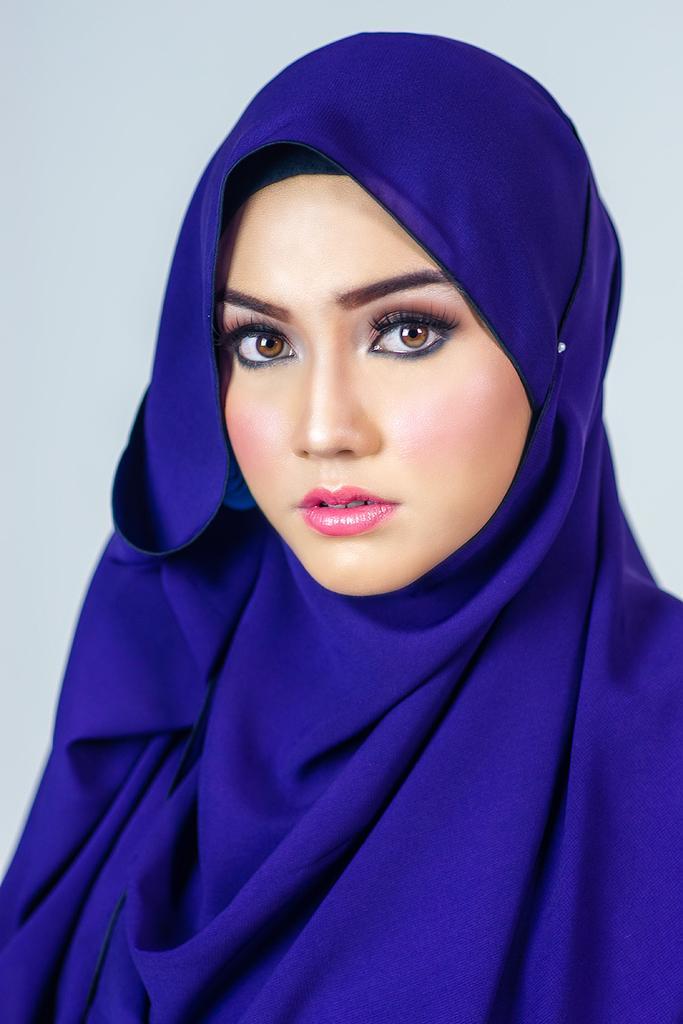Describe this image in one or two sentences. In this picture there is a woman who is wearing blue scarf. She looks very beautiful. At the back there is a wall. 